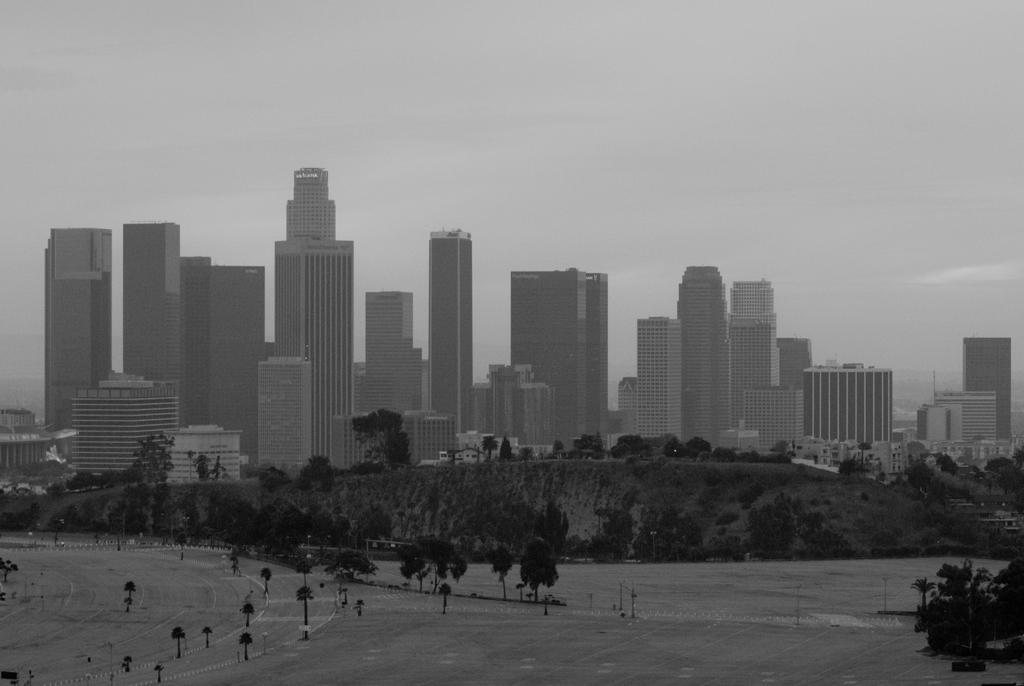Can you describe this image briefly? In this image there are trees, mountains and buildings. 